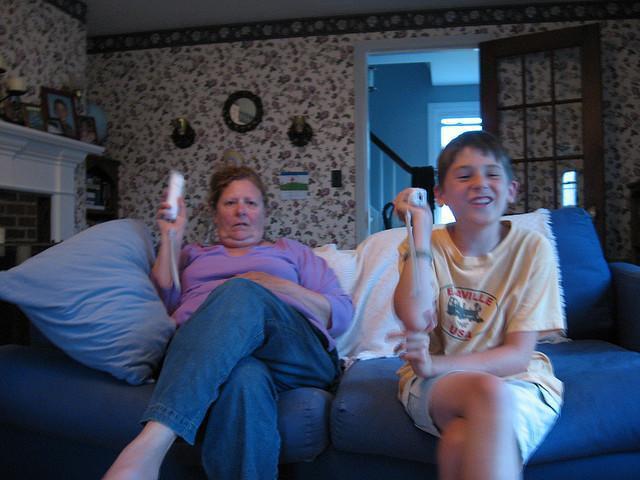Verify the accuracy of this image caption: "The couch is beneath the person.".
Answer yes or no. Yes. Evaluate: Does the caption "The couch is touching the person." match the image?
Answer yes or no. Yes. 